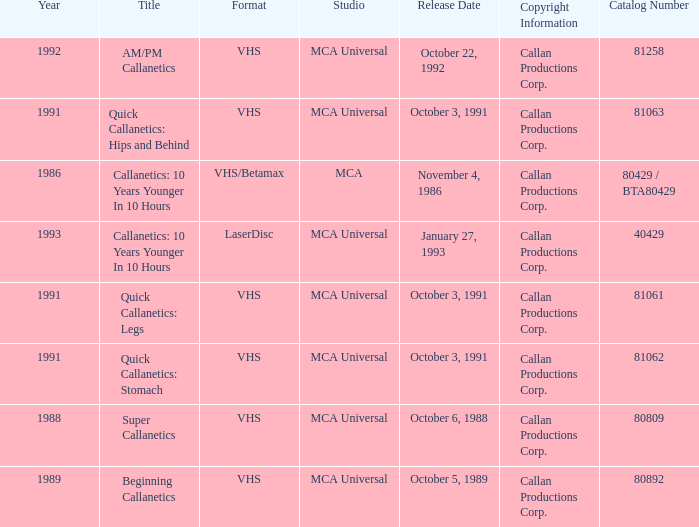Name the catalog number for am/pm callanetics 81258.0. 